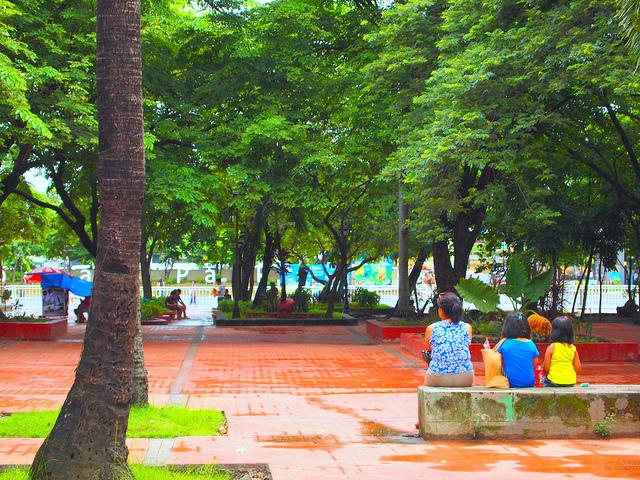Is it a nice day?
Answer briefly. Yes. Are they sitting on a bench?
Give a very brief answer. Yes. What color is the T shirt of the girl that is in the middle?
Concise answer only. Blue. 